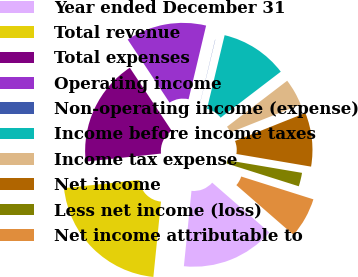Convert chart to OTSL. <chart><loc_0><loc_0><loc_500><loc_500><pie_chart><fcel>Year ended December 31<fcel>Total revenue<fcel>Total expenses<fcel>Operating income<fcel>Non-operating income (expense)<fcel>Income before income taxes<fcel>Income tax expense<fcel>Net income<fcel>Less net income (loss)<fcel>Net income attributable to<nl><fcel>15.2%<fcel>21.71%<fcel>17.37%<fcel>13.04%<fcel>0.03%<fcel>10.87%<fcel>4.36%<fcel>8.7%<fcel>2.2%<fcel>6.53%<nl></chart> 